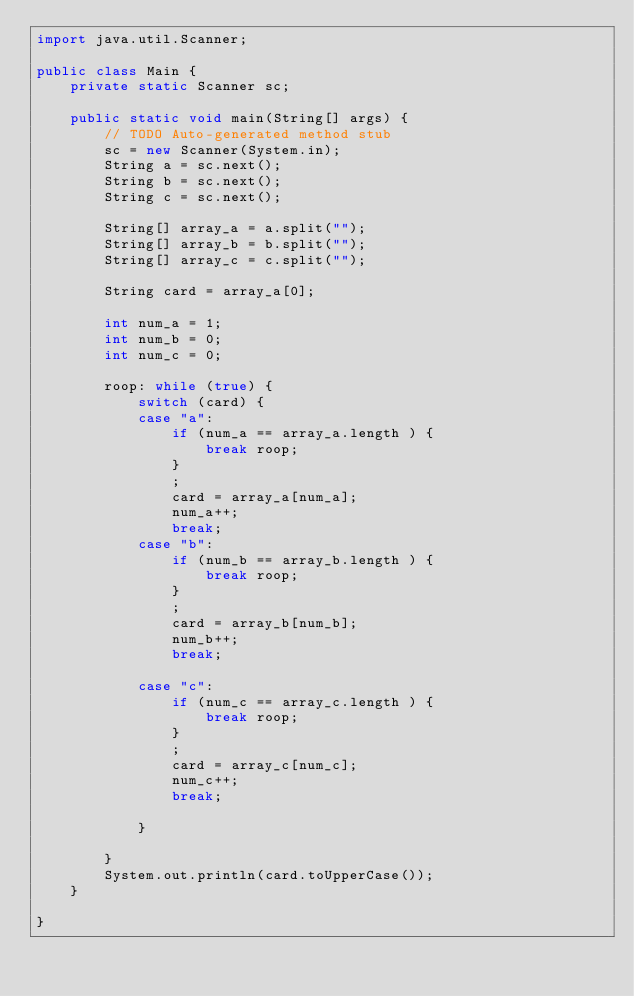<code> <loc_0><loc_0><loc_500><loc_500><_Java_>import java.util.Scanner;

public class Main {
	private static Scanner sc;

	public static void main(String[] args) {
		// TODO Auto-generated method stub
		sc = new Scanner(System.in);
		String a = sc.next();
		String b = sc.next();
		String c = sc.next();

		String[] array_a = a.split("");
		String[] array_b = b.split("");
		String[] array_c = c.split("");

		String card = array_a[0];

		int num_a = 1;
		int num_b = 0;
		int num_c = 0;

		roop: while (true) {
			switch (card) {
			case "a":
				if (num_a == array_a.length ) {
					break roop;
				}
				;
				card = array_a[num_a];
				num_a++;
				break;
			case "b":
				if (num_b == array_b.length ) {
					break roop;
				}
				;
				card = array_b[num_b];
				num_b++;
				break;

			case "c":
				if (num_c == array_c.length ) {
					break roop;
				}
				;
				card = array_c[num_c];
				num_c++;
				break;

			}

		}
		System.out.println(card.toUpperCase());
	}

}</code> 